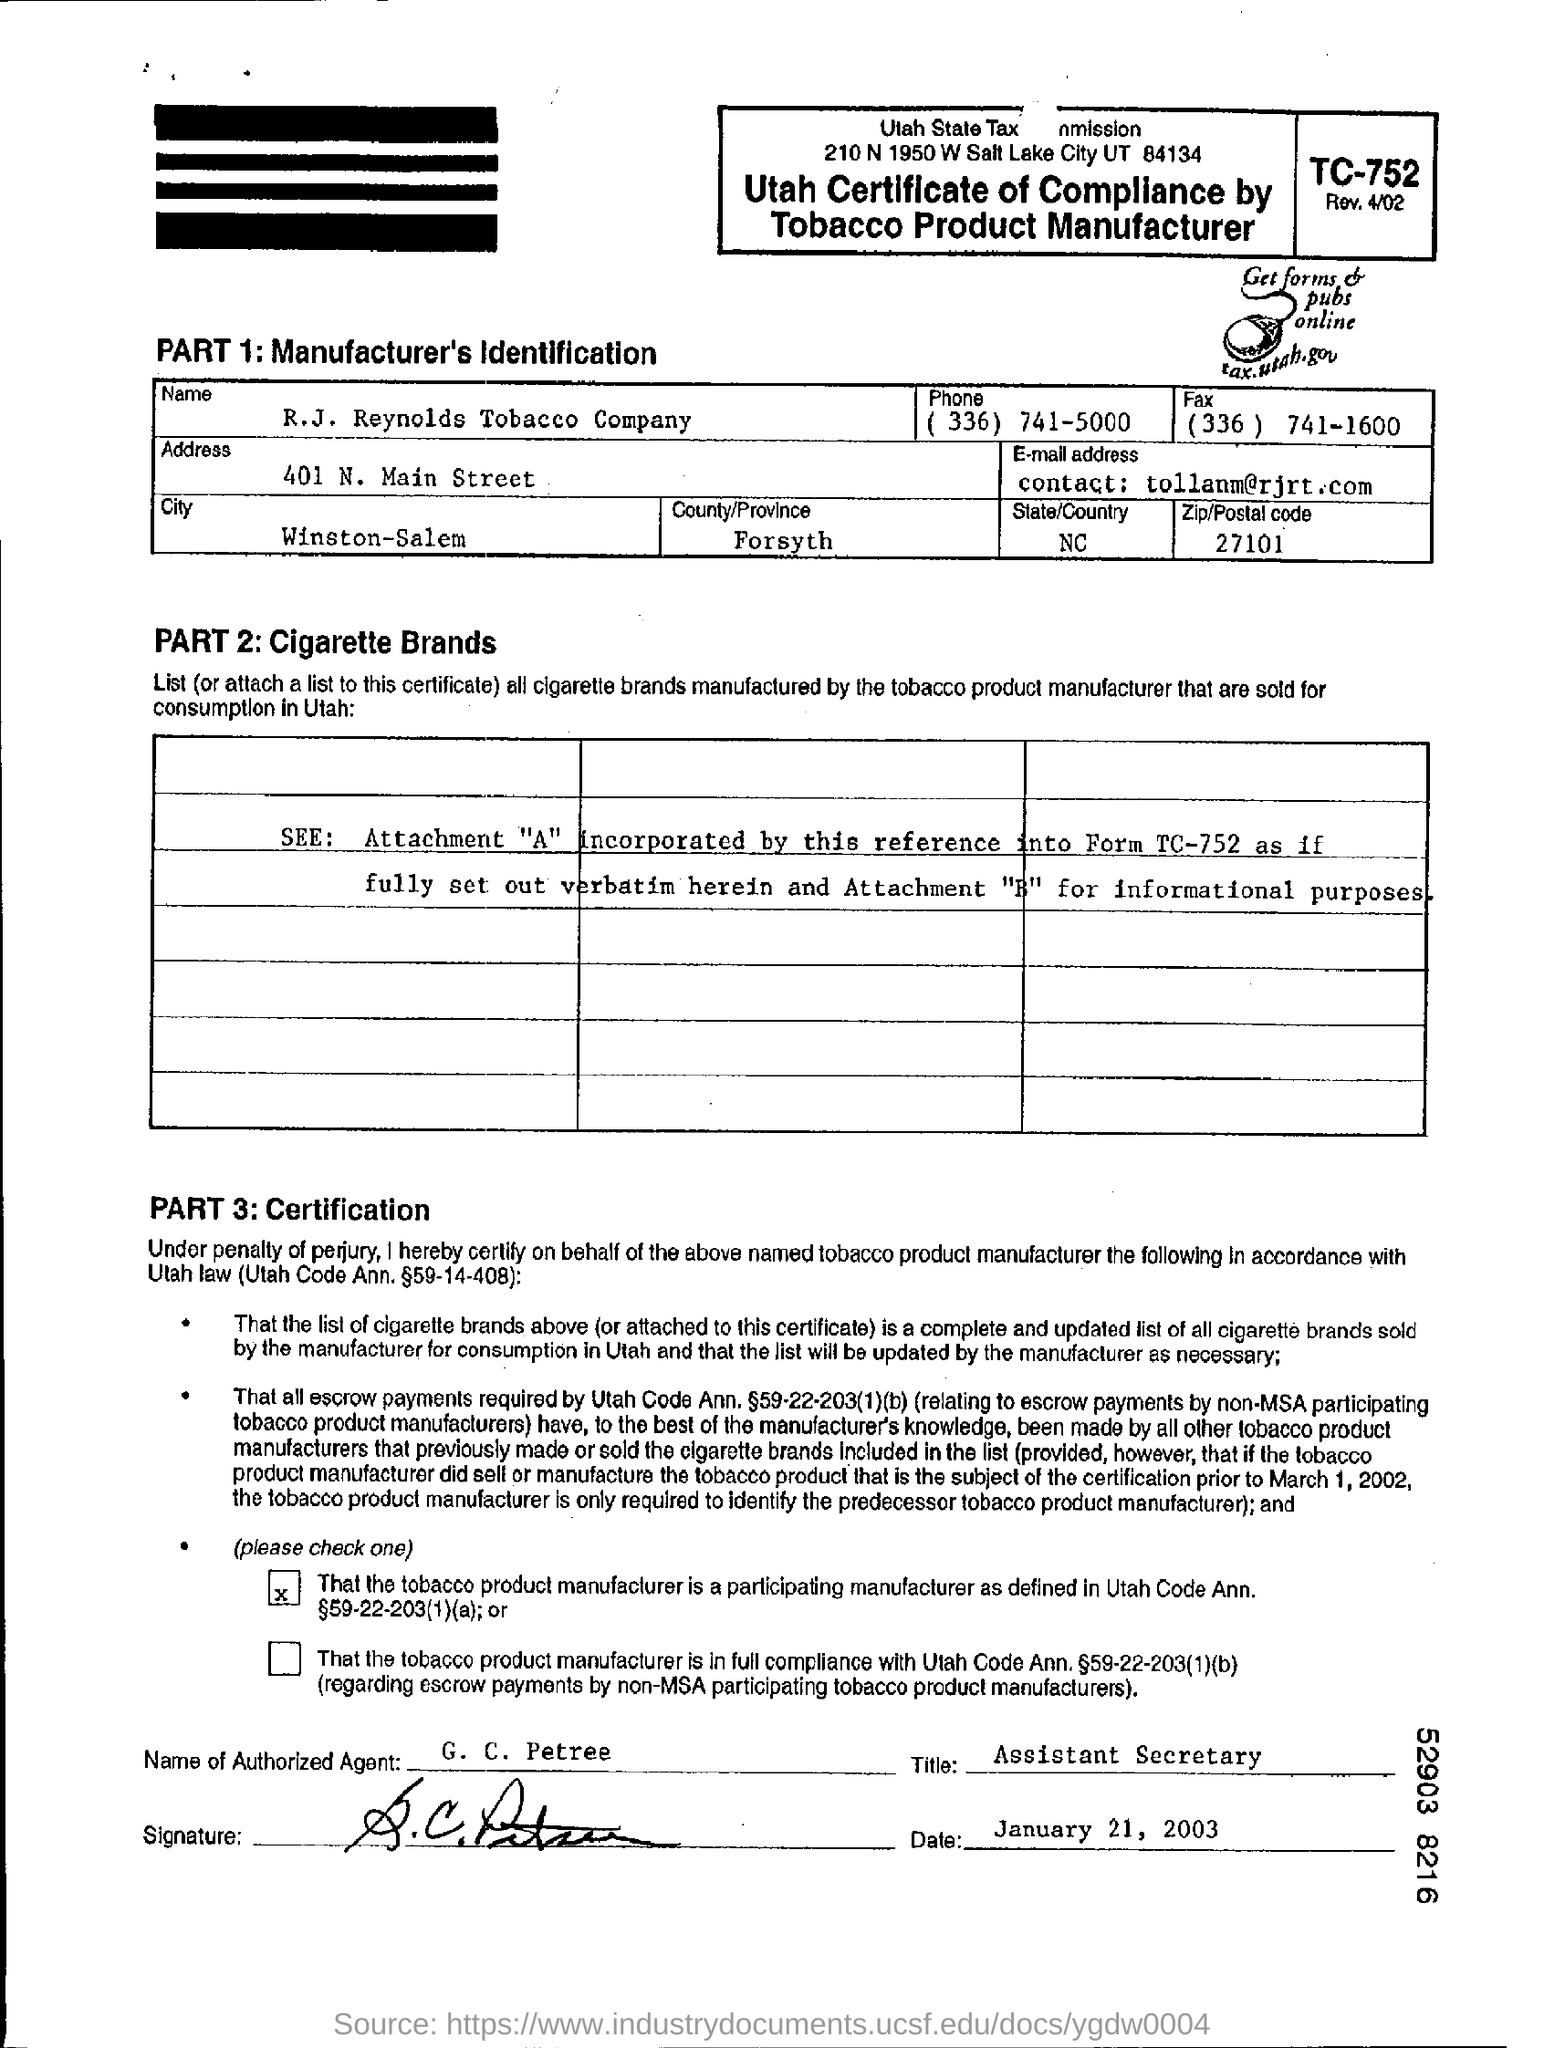Specify some key components in this picture. The company is located in Forsyth, a country or province. You can find certification in part 3. The Utah tax website, tax.utah.gov, provides forms and publications that can be accessed online. In the first part of the item, the manufacturer's identification can be found. The certificate was signed on January 21, 2003. 